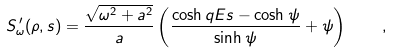Convert formula to latex. <formula><loc_0><loc_0><loc_500><loc_500>S ^ { \, \prime } _ { \omega } ( \rho , s ) = \frac { \sqrt { \omega ^ { 2 } + a ^ { 2 } } } a \left ( \frac { \cosh q E s - \cosh \psi } { \sinh \psi } + \psi \right ) \quad ,</formula> 